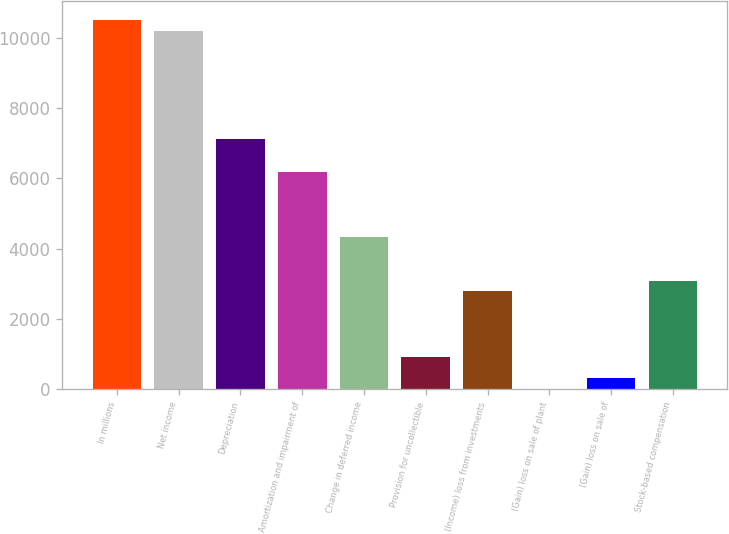Convert chart to OTSL. <chart><loc_0><loc_0><loc_500><loc_500><bar_chart><fcel>In millions<fcel>Net income<fcel>Depreciation<fcel>Amortization and impairment of<fcel>Change in deferred income<fcel>Provision for uncollectible<fcel>(Income) loss from investments<fcel>(Gain) loss on sale of plant<fcel>(Gain) loss on sale of<fcel>Stock-based compensation<nl><fcel>10517.2<fcel>10207.9<fcel>7114.9<fcel>6187<fcel>4331.2<fcel>928.9<fcel>2784.7<fcel>1<fcel>310.3<fcel>3094<nl></chart> 